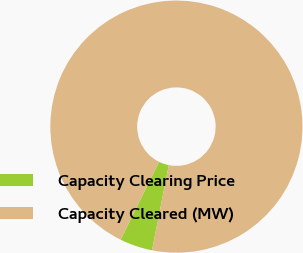Convert chart. <chart><loc_0><loc_0><loc_500><loc_500><pie_chart><fcel>Capacity Clearing Price<fcel>Capacity Cleared (MW)<nl><fcel>4.2%<fcel>95.8%<nl></chart> 